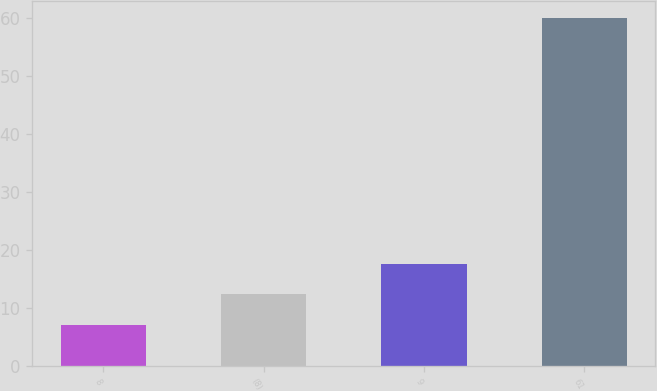Convert chart. <chart><loc_0><loc_0><loc_500><loc_500><bar_chart><fcel>8<fcel>(8)<fcel>9<fcel>61<nl><fcel>7<fcel>12.3<fcel>17.6<fcel>60<nl></chart> 